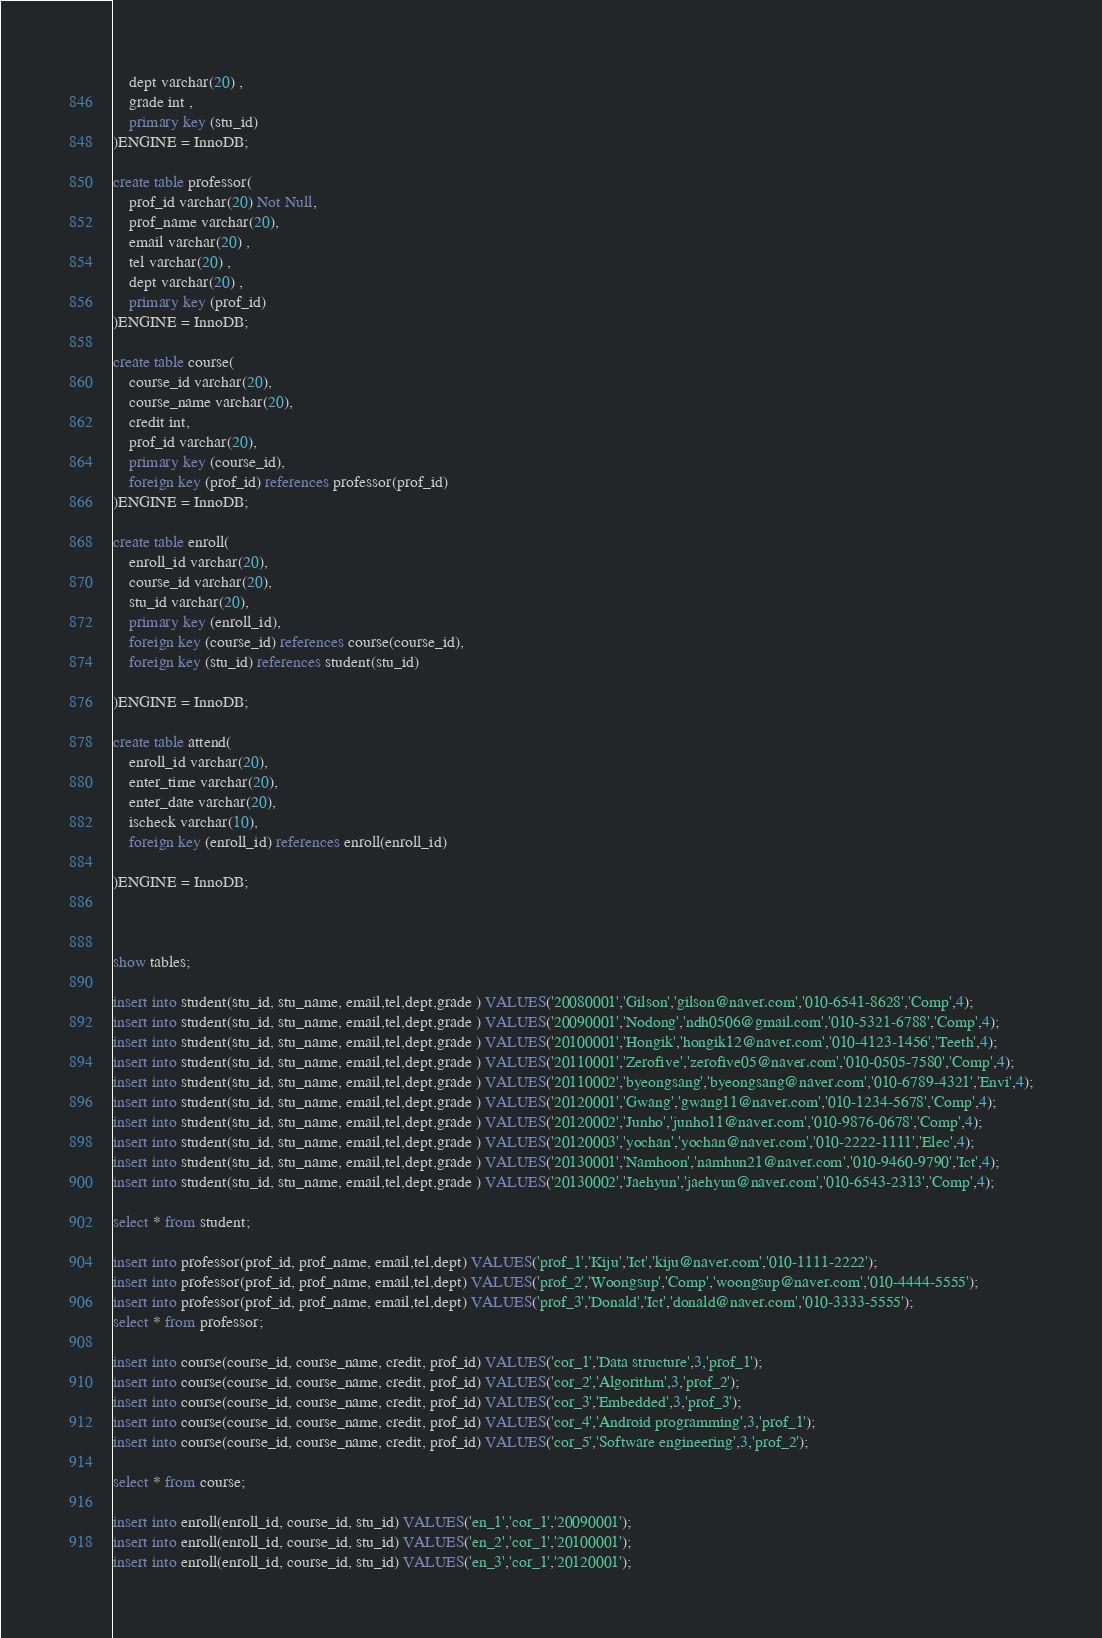Convert code to text. <code><loc_0><loc_0><loc_500><loc_500><_SQL_>    dept varchar(20) ,
    grade int ,
    primary key (stu_id)
)ENGINE = InnoDB;

create table professor(
	prof_id varchar(20) Not Null,
    prof_name varchar(20),
    email varchar(20) ,
	tel varchar(20) ,
    dept varchar(20) ,
    primary key (prof_id)
)ENGINE = InnoDB;

create table course(
	course_id varchar(20),
	course_name varchar(20),
    credit int,
    prof_id varchar(20),
    primary key (course_id),
    foreign key (prof_id) references professor(prof_id) 
)ENGINE = InnoDB;

create table enroll(
	enroll_id varchar(20),
    course_id varchar(20),
    stu_id varchar(20),
    primary key (enroll_id),
    foreign key (course_id) references course(course_id),
    foreign key (stu_id) references student(stu_id)
    
)ENGINE = InnoDB;

create table attend(
	enroll_id varchar(20),
    enter_time varchar(20),
    enter_date varchar(20),
    ischeck varchar(10),
	foreign key (enroll_id) references enroll(enroll_id)
    
)ENGINE = InnoDB;



show tables;

insert into student(stu_id, stu_name, email,tel,dept,grade ) VALUES('20080001','Gilson','gilson@naver.com','010-6541-8628','Comp',4);
insert into student(stu_id, stu_name, email,tel,dept,grade ) VALUES('20090001','Nodong','ndh0506@gmail.com','010-5321-6788','Comp',4);
insert into student(stu_id, stu_name, email,tel,dept,grade ) VALUES('20100001','Hongik','hongik12@naver.com','010-4123-1456','Teeth',4);
insert into student(stu_id, stu_name, email,tel,dept,grade ) VALUES('20110001','Zerofive','zerofive05@naver.com','010-0505-7580','Comp',4);
insert into student(stu_id, stu_name, email,tel,dept,grade ) VALUES('20110002','byeongsang','byeongsang@naver.com','010-6789-4321','Envi',4);
insert into student(stu_id, stu_name, email,tel,dept,grade ) VALUES('20120001','Gwang','gwang11@naver.com','010-1234-5678','Comp',4);
insert into student(stu_id, stu_name, email,tel,dept,grade ) VALUES('20120002','Junho','junho11@naver.com','010-9876-0678','Comp',4);
insert into student(stu_id, stu_name, email,tel,dept,grade ) VALUES('20120003','yochan','yochan@naver.com','010-2222-1111','Elec',4);
insert into student(stu_id, stu_name, email,tel,dept,grade ) VALUES('20130001','Namhoon','namhun21@naver.com','010-9460-9790','Ict',4);
insert into student(stu_id, stu_name, email,tel,dept,grade ) VALUES('20130002','Jaehyun','jaehyun@naver.com','010-6543-2313','Comp',4);

select * from student;

insert into professor(prof_id, prof_name, email,tel,dept) VALUES('prof_1','Kiju','Ict','kiju@naver.com','010-1111-2222');
insert into professor(prof_id, prof_name, email,tel,dept) VALUES('prof_2','Woongsup','Comp','woongsup@naver.com','010-4444-5555');
insert into professor(prof_id, prof_name, email,tel,dept) VALUES('prof_3','Donald','Ict','donald@naver.com','010-3333-5555');
select * from professor;

insert into course(course_id, course_name, credit, prof_id) VALUES('cor_1','Data structure',3,'prof_1');
insert into course(course_id, course_name, credit, prof_id) VALUES('cor_2','Algorithm',3,'prof_2');
insert into course(course_id, course_name, credit, prof_id) VALUES('cor_3','Embedded',3,'prof_3');
insert into course(course_id, course_name, credit, prof_id) VALUES('cor_4','Android programming',3,'prof_1');
insert into course(course_id, course_name, credit, prof_id) VALUES('cor_5','Software engineering',3,'prof_2');

select * from course;

insert into enroll(enroll_id, course_id, stu_id) VALUES('en_1','cor_1','20090001');
insert into enroll(enroll_id, course_id, stu_id) VALUES('en_2','cor_1','20100001');
insert into enroll(enroll_id, course_id, stu_id) VALUES('en_3','cor_1','20120001');</code> 